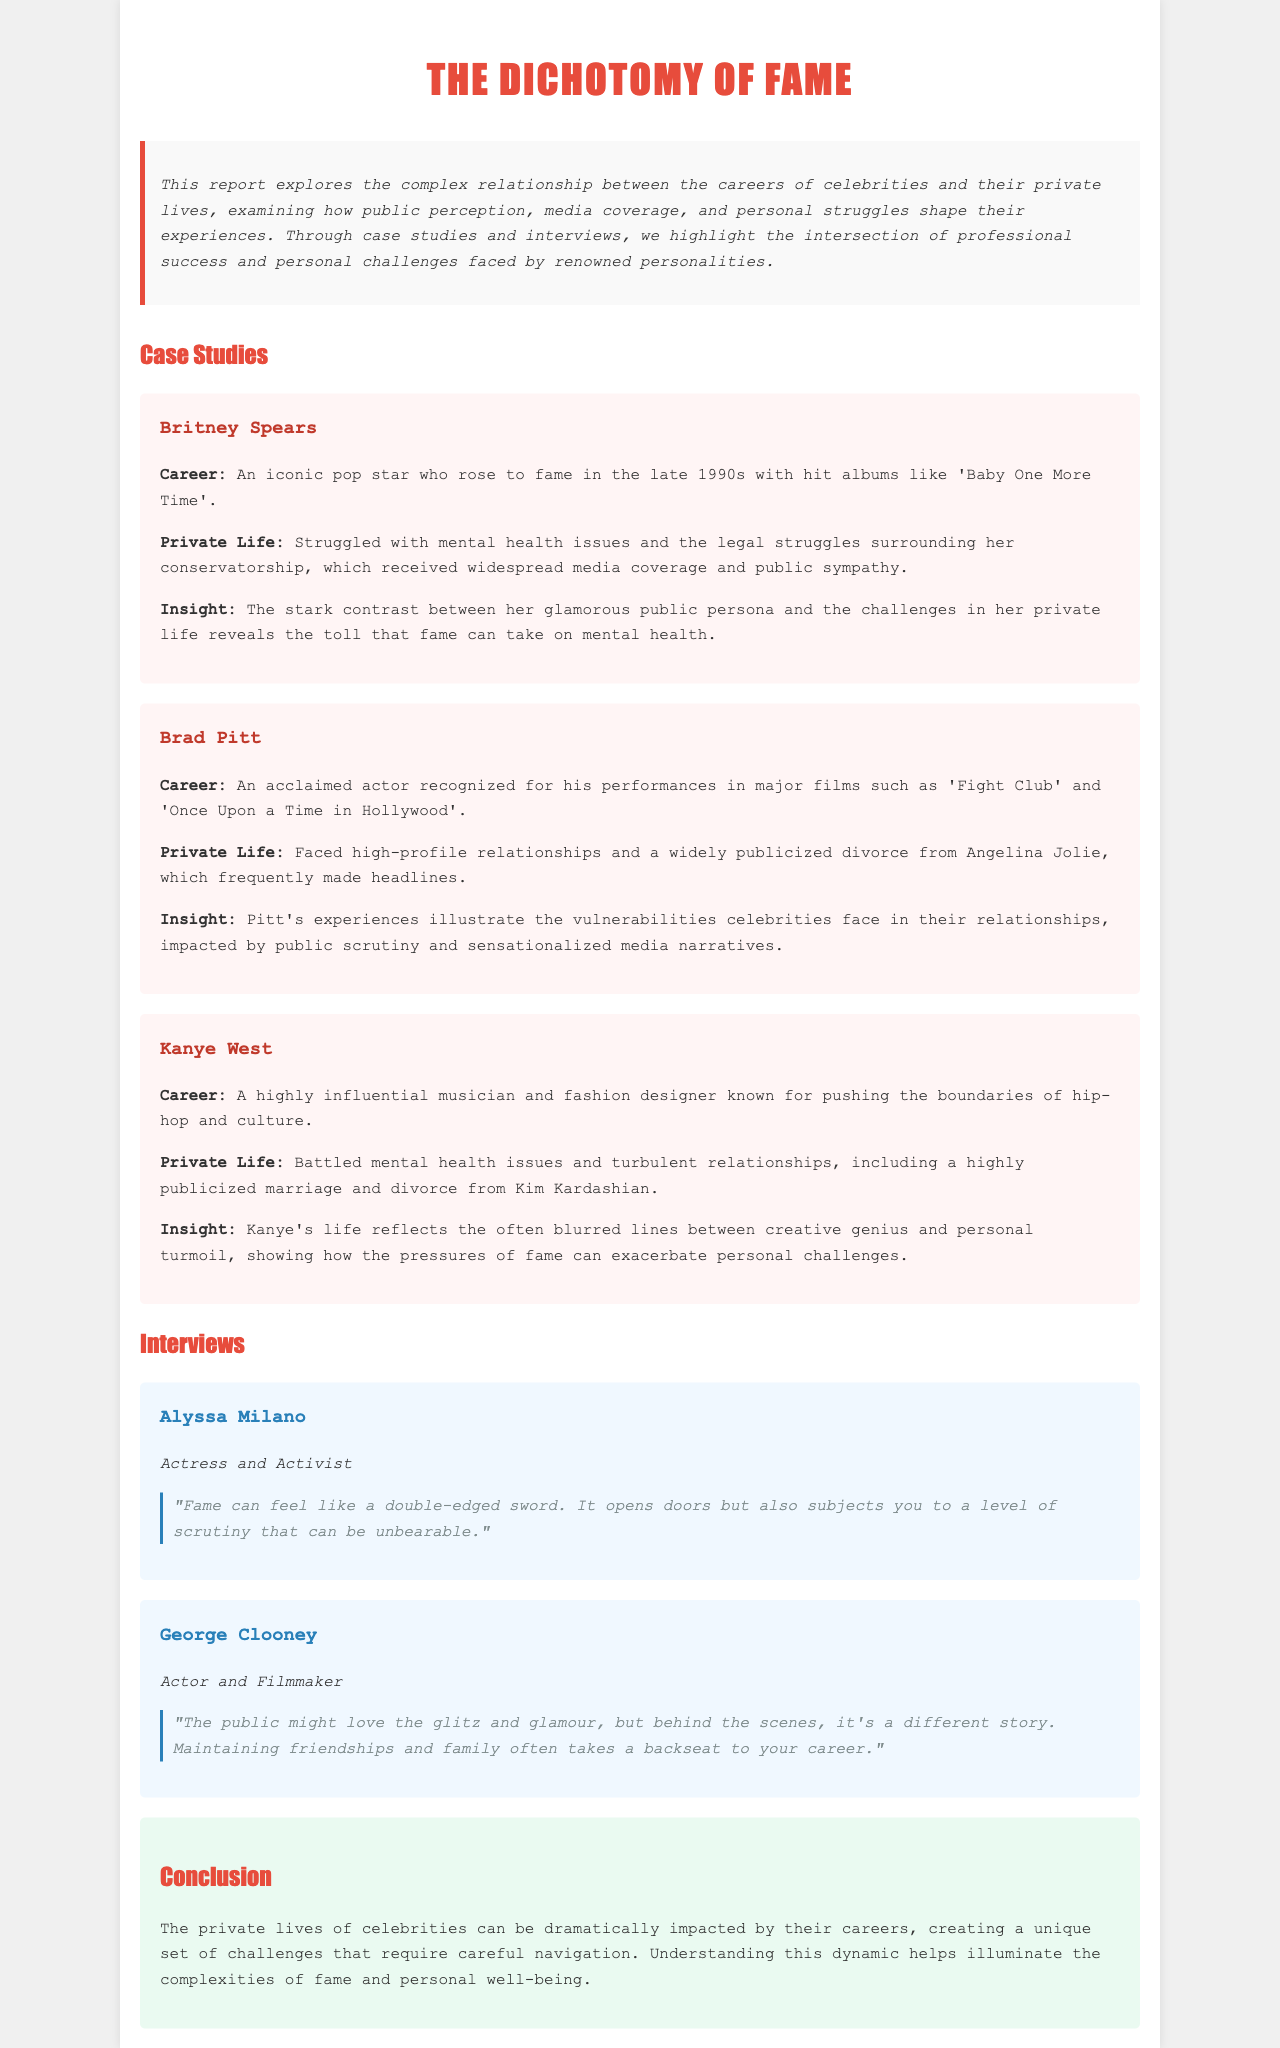What is the title of the report? The title of the report is presented in the heading of the document.
Answer: The Dichotomy of Fame Who is the first case study mentioned? The first case study discussed in the document highlights a particular celebrity's career and personal life.
Answer: Britney Spears What year did Britney Spears rise to fame? The document provides information about the timing of Britney's rise to fame as the late 1990s.
Answer: Late 1990s Who is the actor associated with 'Fight Club'? This question refers to the specific celebrity known for their acclaimed films mentioned in the case studies.
Answer: Brad Pitt What does Alyssa Milano describe fame as? The quote from Alyssa Milano reveals her perspective on the nature of fame.
Answer: A double-edged sword Which celebrity had a highly publicized marriage to Kim Kardashian? This question asks for the celebrity's name that is linked to a well-known relationship mentioned in the document.
Answer: Kanye West How is George Clooney's perspective on public life summarized? The document features a quote that encapsulates Clooney's thoughts about fame and personal relationships.
Answer: Glitz and glamour What is the overall theme discussed in the conclusion? This question addresses the main focus of the report as summarized in the conclusion section.
Answer: Impact of careers on private lives 